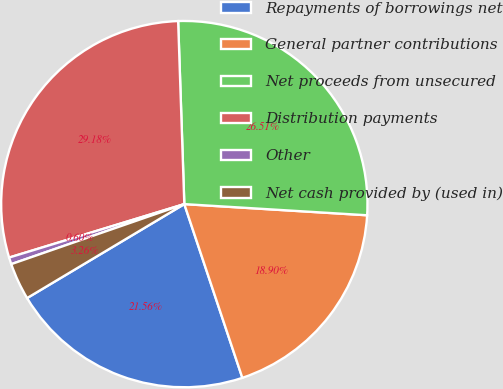Convert chart to OTSL. <chart><loc_0><loc_0><loc_500><loc_500><pie_chart><fcel>Repayments of borrowings net<fcel>General partner contributions<fcel>Net proceeds from unsecured<fcel>Distribution payments<fcel>Other<fcel>Net cash provided by (used in)<nl><fcel>21.56%<fcel>18.9%<fcel>26.51%<fcel>29.18%<fcel>0.6%<fcel>3.26%<nl></chart> 